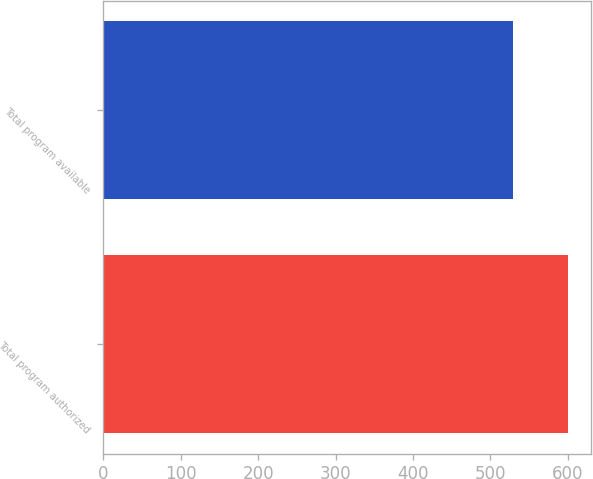Convert chart. <chart><loc_0><loc_0><loc_500><loc_500><bar_chart><fcel>Total program authorized<fcel>Total program available<nl><fcel>600<fcel>529.6<nl></chart> 